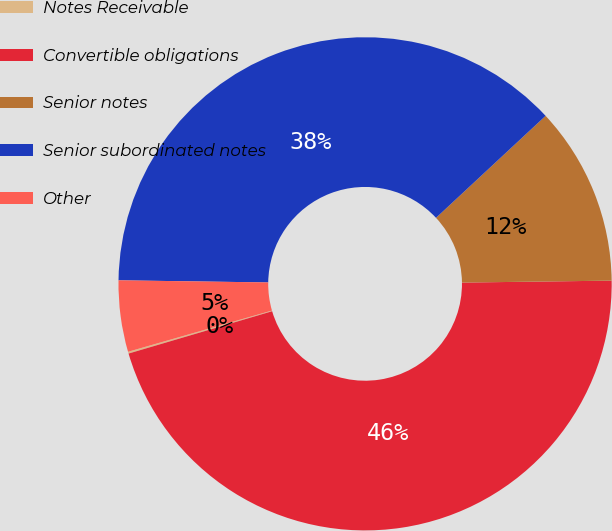<chart> <loc_0><loc_0><loc_500><loc_500><pie_chart><fcel>Notes Receivable<fcel>Convertible obligations<fcel>Senior notes<fcel>Senior subordinated notes<fcel>Other<nl><fcel>0.12%<fcel>45.64%<fcel>11.72%<fcel>37.84%<fcel>4.67%<nl></chart> 